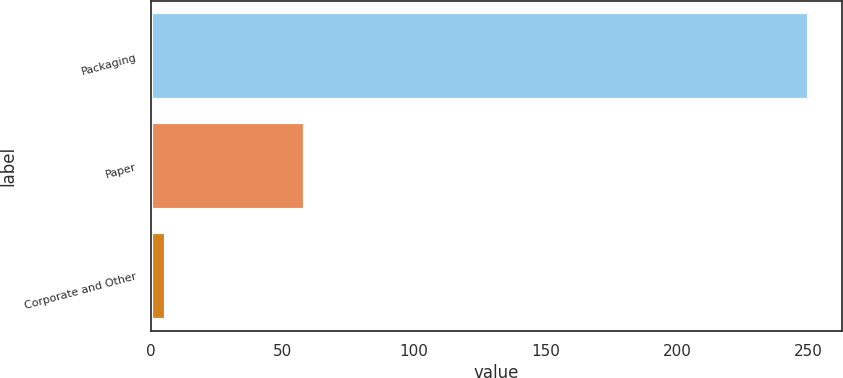Convert chart to OTSL. <chart><loc_0><loc_0><loc_500><loc_500><bar_chart><fcel>Packaging<fcel>Paper<fcel>Corporate and Other<nl><fcel>250.3<fcel>58.5<fcel>5.7<nl></chart> 